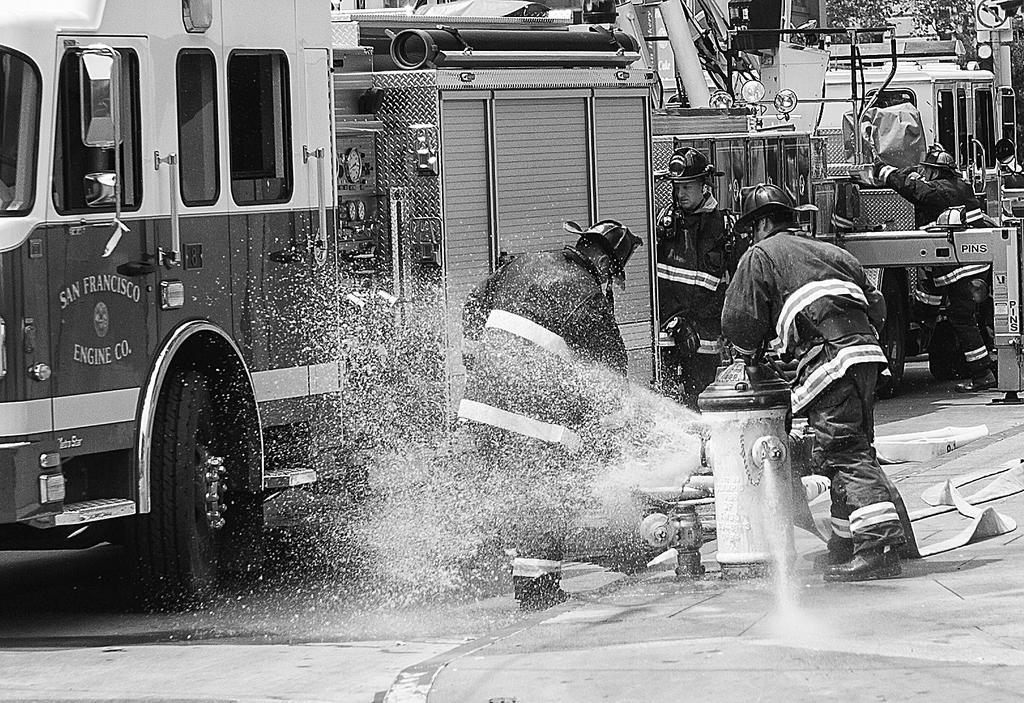How many people are in the image? There is a group of people in the image, but the exact number is not specified. What are some people doing in the image? Some people are standing near a water hydrant. What else can be seen in the image besides the people? Vehicles and trees are visible in the image. How many icicles are hanging from the trees in the image? There is no mention of icicles in the image; it only states that trees are visible. What type of fruit is present on the quince tree in the image? There is no quince tree or fruit mentioned in the image; it only states that trees are visible. 